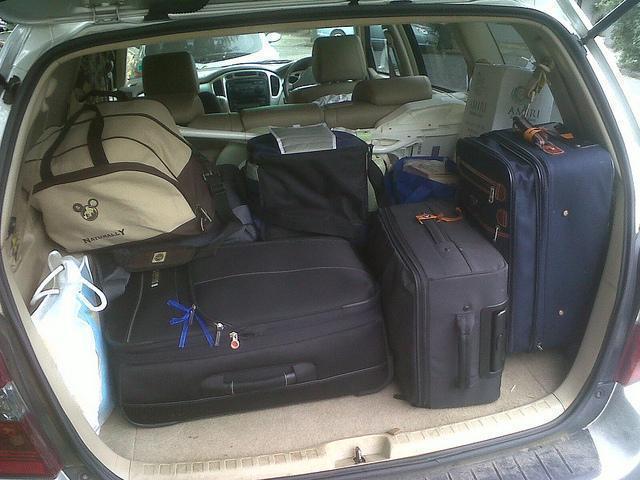Why would this person load the back of their car with these?
Choose the right answer from the provided options to respond to the question.
Options: Delivery driver, work tools, road trip, add weight. Road trip. 